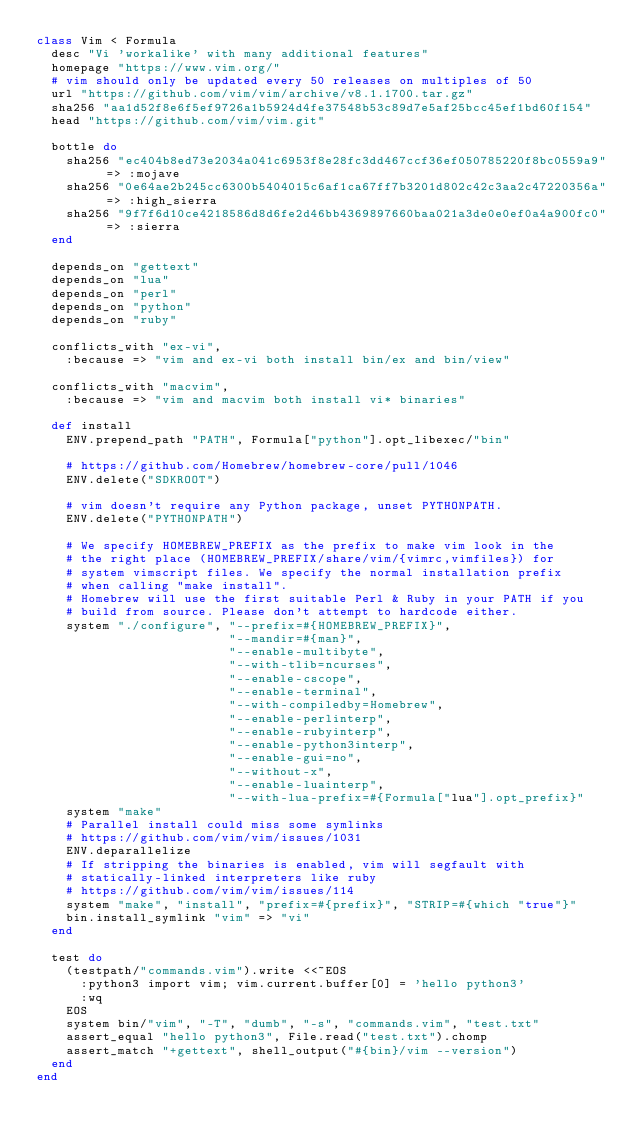<code> <loc_0><loc_0><loc_500><loc_500><_Ruby_>class Vim < Formula
  desc "Vi 'workalike' with many additional features"
  homepage "https://www.vim.org/"
  # vim should only be updated every 50 releases on multiples of 50
  url "https://github.com/vim/vim/archive/v8.1.1700.tar.gz"
  sha256 "aa1d52f8e6f5ef9726a1b5924d4fe37548b53c89d7e5af25bcc45ef1bd60f154"
  head "https://github.com/vim/vim.git"

  bottle do
    sha256 "ec404b8ed73e2034a041c6953f8e28fc3dd467ccf36ef050785220f8bc0559a9" => :mojave
    sha256 "0e64ae2b245cc6300b5404015c6af1ca67ff7b3201d802c42c3aa2c47220356a" => :high_sierra
    sha256 "9f7f6d10ce4218586d8d6fe2d46bb4369897660baa021a3de0e0ef0a4a900fc0" => :sierra
  end

  depends_on "gettext"
  depends_on "lua"
  depends_on "perl"
  depends_on "python"
  depends_on "ruby"

  conflicts_with "ex-vi",
    :because => "vim and ex-vi both install bin/ex and bin/view"

  conflicts_with "macvim",
    :because => "vim and macvim both install vi* binaries"

  def install
    ENV.prepend_path "PATH", Formula["python"].opt_libexec/"bin"

    # https://github.com/Homebrew/homebrew-core/pull/1046
    ENV.delete("SDKROOT")

    # vim doesn't require any Python package, unset PYTHONPATH.
    ENV.delete("PYTHONPATH")

    # We specify HOMEBREW_PREFIX as the prefix to make vim look in the
    # the right place (HOMEBREW_PREFIX/share/vim/{vimrc,vimfiles}) for
    # system vimscript files. We specify the normal installation prefix
    # when calling "make install".
    # Homebrew will use the first suitable Perl & Ruby in your PATH if you
    # build from source. Please don't attempt to hardcode either.
    system "./configure", "--prefix=#{HOMEBREW_PREFIX}",
                          "--mandir=#{man}",
                          "--enable-multibyte",
                          "--with-tlib=ncurses",
                          "--enable-cscope",
                          "--enable-terminal",
                          "--with-compiledby=Homebrew",
                          "--enable-perlinterp",
                          "--enable-rubyinterp",
                          "--enable-python3interp",
                          "--enable-gui=no",
                          "--without-x",
                          "--enable-luainterp",
                          "--with-lua-prefix=#{Formula["lua"].opt_prefix}"
    system "make"
    # Parallel install could miss some symlinks
    # https://github.com/vim/vim/issues/1031
    ENV.deparallelize
    # If stripping the binaries is enabled, vim will segfault with
    # statically-linked interpreters like ruby
    # https://github.com/vim/vim/issues/114
    system "make", "install", "prefix=#{prefix}", "STRIP=#{which "true"}"
    bin.install_symlink "vim" => "vi"
  end

  test do
    (testpath/"commands.vim").write <<~EOS
      :python3 import vim; vim.current.buffer[0] = 'hello python3'
      :wq
    EOS
    system bin/"vim", "-T", "dumb", "-s", "commands.vim", "test.txt"
    assert_equal "hello python3", File.read("test.txt").chomp
    assert_match "+gettext", shell_output("#{bin}/vim --version")
  end
end
</code> 